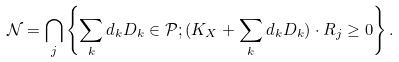Convert formula to latex. <formula><loc_0><loc_0><loc_500><loc_500>\mathcal { N } = \bigcap _ { j } \left \{ \sum _ { k } d _ { k } D _ { k } \in \mathcal { P } ; ( K _ { X } + \sum _ { k } d _ { k } D _ { k } ) \cdot R _ { j } \geq 0 \right \} .</formula> 